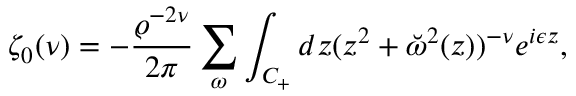<formula> <loc_0><loc_0><loc_500><loc_500>\zeta _ { 0 } ( \nu ) = - { \frac { \varrho ^ { - 2 \nu } } { 2 \pi } } \sum _ { \omega } \int _ { C _ { + } } d z ( z ^ { 2 } + \breve { \omega } ^ { 2 } ( z ) ) ^ { - \nu } e ^ { i \epsilon z } ,</formula> 